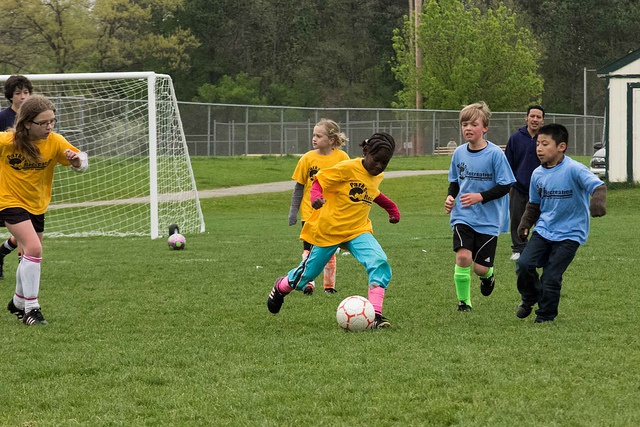Describe the objects in this image and their specific colors. I can see people in olive, black, darkgray, and blue tones, people in olive, orange, black, and teal tones, people in olive, black, and orange tones, people in olive, black, darkgray, and gray tones, and people in olive, orange, and gray tones in this image. 